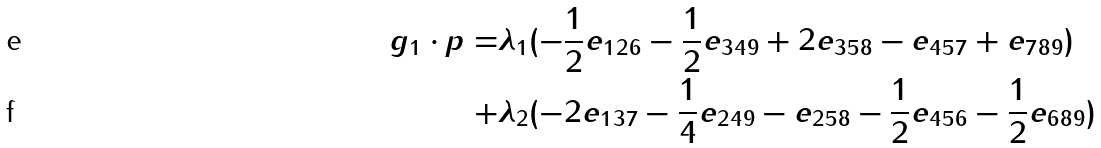<formula> <loc_0><loc_0><loc_500><loc_500>g _ { 1 } \cdot p = & \lambda _ { 1 } ( - \frac { 1 } { 2 } e _ { 1 2 6 } - \frac { 1 } { 2 } e _ { 3 4 9 } + 2 e _ { 3 5 8 } - e _ { 4 5 7 } + e _ { 7 8 9 } ) \\ + & \lambda _ { 2 } ( - 2 e _ { 1 3 7 } - \frac { 1 } { 4 } e _ { 2 4 9 } - e _ { 2 5 8 } - \frac { 1 } { 2 } e _ { 4 5 6 } - \frac { 1 } { 2 } e _ { 6 8 9 } )</formula> 